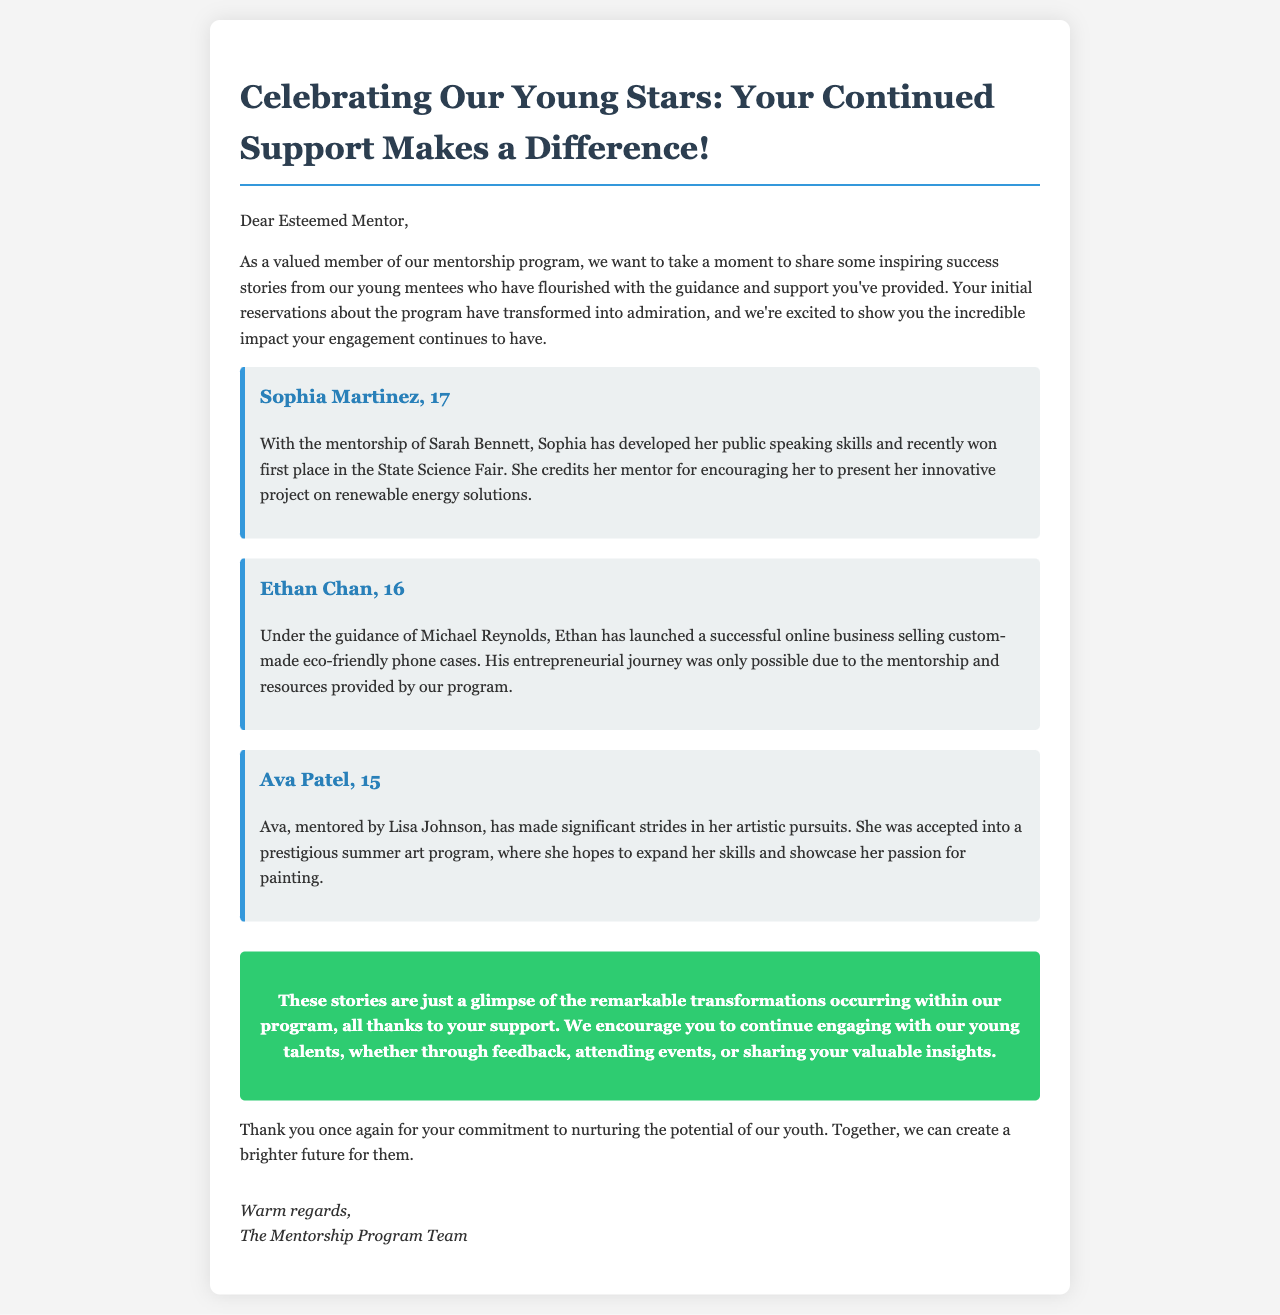what is the title of the document? The title of the document is found in the `<title>` tag, which specifies the main theme or purpose of the mail.
Answer: Celebrating Our Young Stars how many success stories are detailed in the document? The document lists three distinct success stories of young mentees, each detailed in a separate section.
Answer: 3 who is the mentor of Sophia Martinez? The mentor's name is provided within Sophia's success story as the individual who guided her development in public speaking.
Answer: Sarah Bennett what skill did Ethan Chan develop? The success story about Ethan specifies that he developed entrepreneurial skills through launching a business.
Answer: entrepreneurial what was Ava Patel accepted into? Ava's success story mentions a prestigious program that she was accepted into for furthering her artistic skills.
Answer: summer art program which mentee presented a project on renewable energy solutions? The document outlines that Sophia Martinez presented a project related to renewable energy at the State Science Fair.
Answer: Sophia Martinez what is the main purpose of this document? The document serves to celebrate the success of young mentees and encourage continued support and engagement from mentors.
Answer: celebrate success what is included in the call-to-action section? The call-to-action explains how mentors can continue to engage with young talents through various means.
Answer: continue engaging 